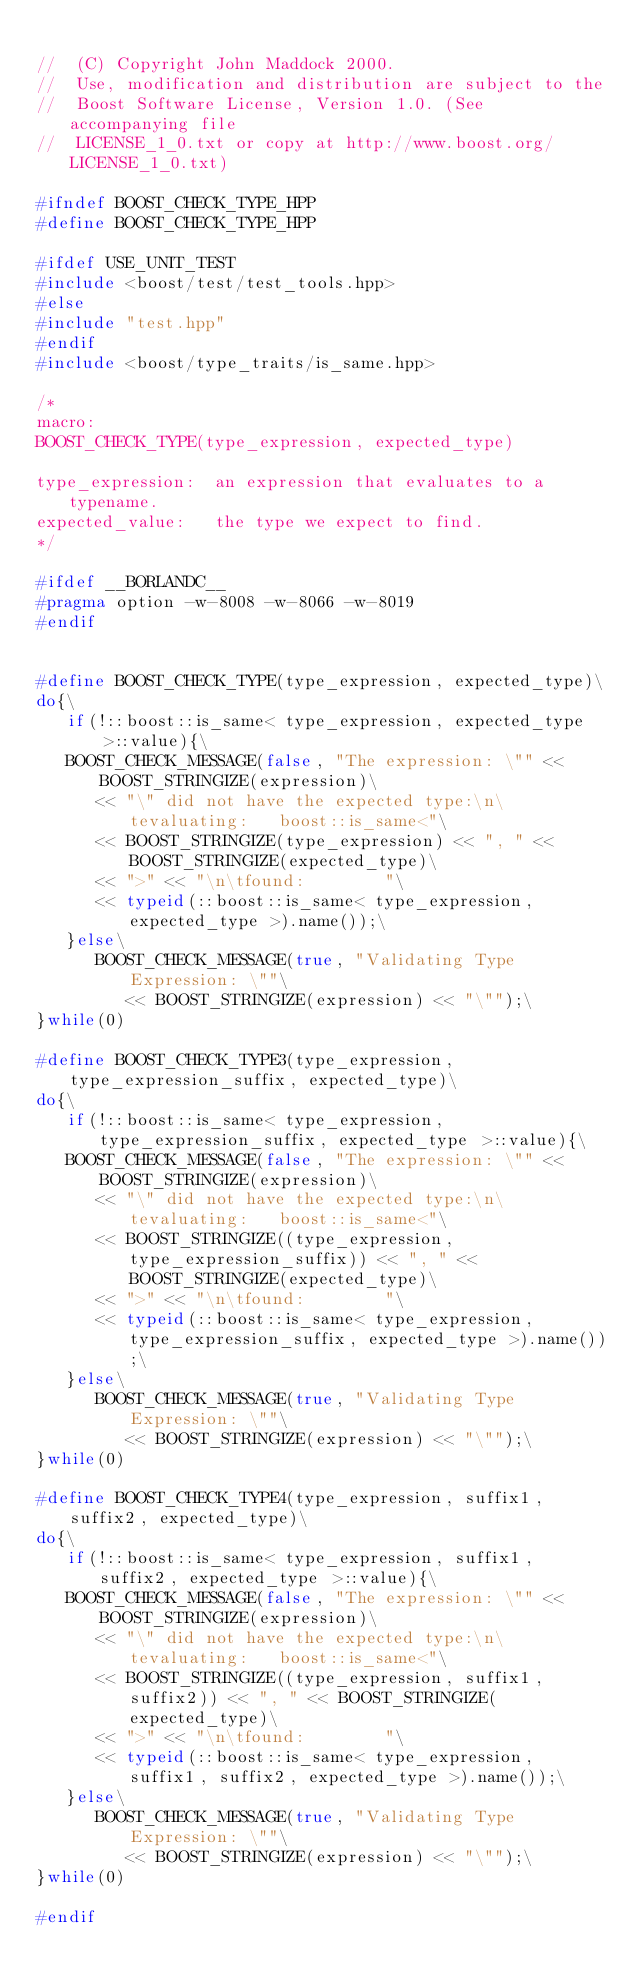<code> <loc_0><loc_0><loc_500><loc_500><_C++_>
//  (C) Copyright John Maddock 2000. 
//  Use, modification and distribution are subject to the 
//  Boost Software License, Version 1.0. (See accompanying file 
//  LICENSE_1_0.txt or copy at http://www.boost.org/LICENSE_1_0.txt)

#ifndef BOOST_CHECK_TYPE_HPP
#define BOOST_CHECK_TYPE_HPP

#ifdef USE_UNIT_TEST
#include <boost/test/test_tools.hpp>
#else
#include "test.hpp"
#endif
#include <boost/type_traits/is_same.hpp>

/*
macro:
BOOST_CHECK_TYPE(type_expression, expected_type)

type_expression:  an expression that evaluates to a typename.
expected_value:   the type we expect to find.
*/

#ifdef __BORLANDC__
#pragma option -w-8008 -w-8066 -w-8019
#endif


#define BOOST_CHECK_TYPE(type_expression, expected_type)\
do{\
   if(!::boost::is_same< type_expression, expected_type >::value){\
   BOOST_CHECK_MESSAGE(false, "The expression: \"" << BOOST_STRINGIZE(expression)\
      << "\" did not have the expected type:\n\tevaluating:   boost::is_same<"\
      << BOOST_STRINGIZE(type_expression) << ", " << BOOST_STRINGIZE(expected_type)\
      << ">" << "\n\tfound:        "\
      << typeid(::boost::is_same< type_expression, expected_type >).name());\
   }else\
      BOOST_CHECK_MESSAGE(true, "Validating Type Expression: \""\
         << BOOST_STRINGIZE(expression) << "\"");\
}while(0)

#define BOOST_CHECK_TYPE3(type_expression, type_expression_suffix, expected_type)\
do{\
   if(!::boost::is_same< type_expression, type_expression_suffix, expected_type >::value){\
   BOOST_CHECK_MESSAGE(false, "The expression: \"" << BOOST_STRINGIZE(expression)\
      << "\" did not have the expected type:\n\tevaluating:   boost::is_same<"\
      << BOOST_STRINGIZE((type_expression, type_expression_suffix)) << ", " << BOOST_STRINGIZE(expected_type)\
      << ">" << "\n\tfound:        "\
      << typeid(::boost::is_same< type_expression, type_expression_suffix, expected_type >).name());\
   }else\
      BOOST_CHECK_MESSAGE(true, "Validating Type Expression: \""\
         << BOOST_STRINGIZE(expression) << "\"");\
}while(0)

#define BOOST_CHECK_TYPE4(type_expression, suffix1, suffix2, expected_type)\
do{\
   if(!::boost::is_same< type_expression, suffix1, suffix2, expected_type >::value){\
   BOOST_CHECK_MESSAGE(false, "The expression: \"" << BOOST_STRINGIZE(expression)\
      << "\" did not have the expected type:\n\tevaluating:   boost::is_same<"\
      << BOOST_STRINGIZE((type_expression, suffix1, suffix2)) << ", " << BOOST_STRINGIZE(expected_type)\
      << ">" << "\n\tfound:        "\
      << typeid(::boost::is_same< type_expression, suffix1, suffix2, expected_type >).name());\
   }else\
      BOOST_CHECK_MESSAGE(true, "Validating Type Expression: \""\
         << BOOST_STRINGIZE(expression) << "\"");\
}while(0)

#endif


</code> 